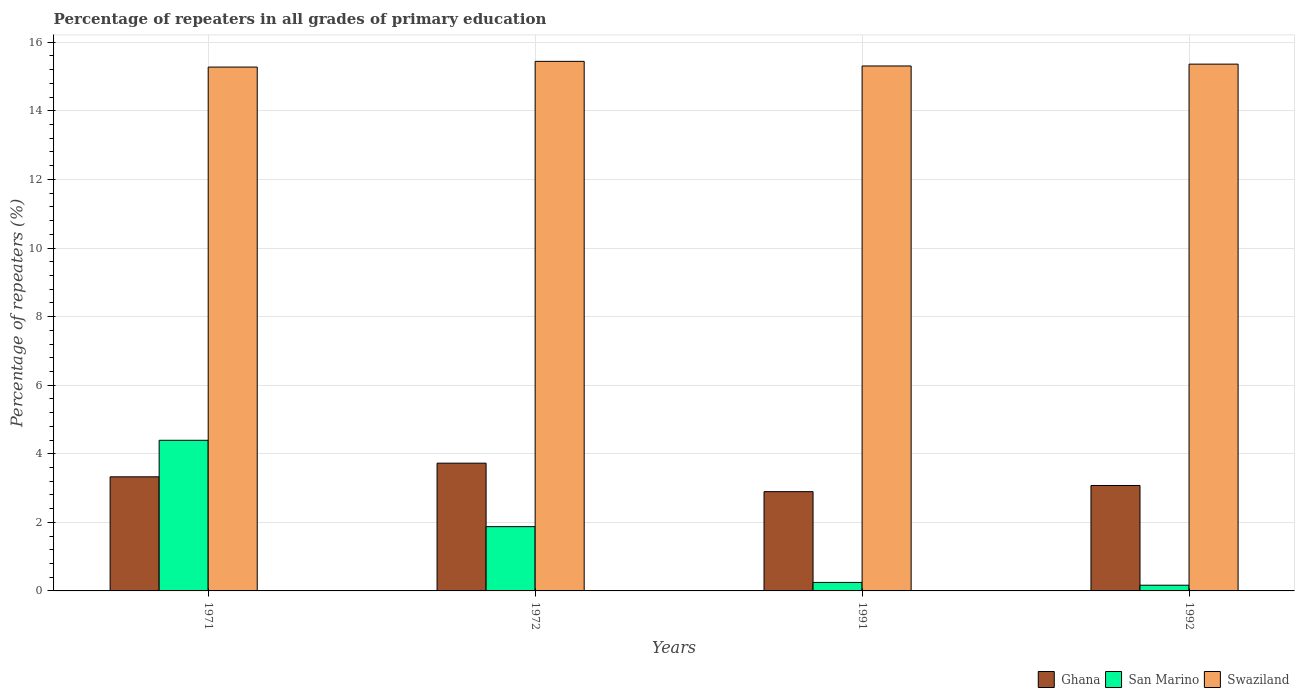How many different coloured bars are there?
Provide a succinct answer. 3. Are the number of bars per tick equal to the number of legend labels?
Provide a succinct answer. Yes. How many bars are there on the 2nd tick from the right?
Give a very brief answer. 3. What is the label of the 1st group of bars from the left?
Your response must be concise. 1971. In how many cases, is the number of bars for a given year not equal to the number of legend labels?
Provide a short and direct response. 0. What is the percentage of repeaters in San Marino in 1992?
Your answer should be compact. 0.17. Across all years, what is the maximum percentage of repeaters in Ghana?
Provide a short and direct response. 3.73. Across all years, what is the minimum percentage of repeaters in Swaziland?
Make the answer very short. 15.28. What is the total percentage of repeaters in Swaziland in the graph?
Your answer should be compact. 61.39. What is the difference between the percentage of repeaters in Ghana in 1971 and that in 1972?
Offer a very short reply. -0.4. What is the difference between the percentage of repeaters in Ghana in 1991 and the percentage of repeaters in Swaziland in 1972?
Your response must be concise. -12.55. What is the average percentage of repeaters in Ghana per year?
Offer a very short reply. 3.26. In the year 1972, what is the difference between the percentage of repeaters in Ghana and percentage of repeaters in San Marino?
Your answer should be very brief. 1.85. What is the ratio of the percentage of repeaters in Swaziland in 1991 to that in 1992?
Your answer should be very brief. 1. What is the difference between the highest and the second highest percentage of repeaters in Ghana?
Keep it short and to the point. 0.4. What is the difference between the highest and the lowest percentage of repeaters in San Marino?
Your answer should be compact. 4.23. Is the sum of the percentage of repeaters in San Marino in 1972 and 1991 greater than the maximum percentage of repeaters in Swaziland across all years?
Your response must be concise. No. What does the 2nd bar from the right in 1991 represents?
Ensure brevity in your answer.  San Marino. Is it the case that in every year, the sum of the percentage of repeaters in San Marino and percentage of repeaters in Ghana is greater than the percentage of repeaters in Swaziland?
Give a very brief answer. No. How many bars are there?
Your answer should be compact. 12. Are all the bars in the graph horizontal?
Provide a short and direct response. No. What is the difference between two consecutive major ticks on the Y-axis?
Your response must be concise. 2. Are the values on the major ticks of Y-axis written in scientific E-notation?
Your response must be concise. No. Where does the legend appear in the graph?
Ensure brevity in your answer.  Bottom right. What is the title of the graph?
Your answer should be compact. Percentage of repeaters in all grades of primary education. What is the label or title of the Y-axis?
Ensure brevity in your answer.  Percentage of repeaters (%). What is the Percentage of repeaters (%) in Ghana in 1971?
Provide a succinct answer. 3.33. What is the Percentage of repeaters (%) in San Marino in 1971?
Offer a very short reply. 4.39. What is the Percentage of repeaters (%) in Swaziland in 1971?
Offer a terse response. 15.28. What is the Percentage of repeaters (%) of Ghana in 1972?
Your answer should be compact. 3.73. What is the Percentage of repeaters (%) of San Marino in 1972?
Offer a very short reply. 1.87. What is the Percentage of repeaters (%) in Swaziland in 1972?
Offer a very short reply. 15.44. What is the Percentage of repeaters (%) in Ghana in 1991?
Provide a short and direct response. 2.9. What is the Percentage of repeaters (%) of San Marino in 1991?
Keep it short and to the point. 0.25. What is the Percentage of repeaters (%) of Swaziland in 1991?
Offer a very short reply. 15.31. What is the Percentage of repeaters (%) of Ghana in 1992?
Keep it short and to the point. 3.07. What is the Percentage of repeaters (%) of San Marino in 1992?
Offer a terse response. 0.17. What is the Percentage of repeaters (%) in Swaziland in 1992?
Offer a very short reply. 15.36. Across all years, what is the maximum Percentage of repeaters (%) in Ghana?
Your answer should be compact. 3.73. Across all years, what is the maximum Percentage of repeaters (%) of San Marino?
Ensure brevity in your answer.  4.39. Across all years, what is the maximum Percentage of repeaters (%) of Swaziland?
Your response must be concise. 15.44. Across all years, what is the minimum Percentage of repeaters (%) in Ghana?
Offer a very short reply. 2.9. Across all years, what is the minimum Percentage of repeaters (%) in San Marino?
Offer a very short reply. 0.17. Across all years, what is the minimum Percentage of repeaters (%) of Swaziland?
Provide a short and direct response. 15.28. What is the total Percentage of repeaters (%) of Ghana in the graph?
Keep it short and to the point. 13.02. What is the total Percentage of repeaters (%) of San Marino in the graph?
Offer a terse response. 6.68. What is the total Percentage of repeaters (%) of Swaziland in the graph?
Your response must be concise. 61.39. What is the difference between the Percentage of repeaters (%) of Ghana in 1971 and that in 1972?
Provide a succinct answer. -0.4. What is the difference between the Percentage of repeaters (%) of San Marino in 1971 and that in 1972?
Your answer should be compact. 2.52. What is the difference between the Percentage of repeaters (%) of Ghana in 1971 and that in 1991?
Ensure brevity in your answer.  0.43. What is the difference between the Percentage of repeaters (%) of San Marino in 1971 and that in 1991?
Give a very brief answer. 4.15. What is the difference between the Percentage of repeaters (%) in Swaziland in 1971 and that in 1991?
Give a very brief answer. -0.03. What is the difference between the Percentage of repeaters (%) in Ghana in 1971 and that in 1992?
Your answer should be compact. 0.25. What is the difference between the Percentage of repeaters (%) of San Marino in 1971 and that in 1992?
Keep it short and to the point. 4.23. What is the difference between the Percentage of repeaters (%) of Swaziland in 1971 and that in 1992?
Give a very brief answer. -0.09. What is the difference between the Percentage of repeaters (%) in Ghana in 1972 and that in 1991?
Provide a succinct answer. 0.83. What is the difference between the Percentage of repeaters (%) of San Marino in 1972 and that in 1991?
Give a very brief answer. 1.63. What is the difference between the Percentage of repeaters (%) in Swaziland in 1972 and that in 1991?
Give a very brief answer. 0.13. What is the difference between the Percentage of repeaters (%) in Ghana in 1972 and that in 1992?
Your response must be concise. 0.65. What is the difference between the Percentage of repeaters (%) of San Marino in 1972 and that in 1992?
Your answer should be very brief. 1.71. What is the difference between the Percentage of repeaters (%) of Swaziland in 1972 and that in 1992?
Your answer should be compact. 0.08. What is the difference between the Percentage of repeaters (%) in Ghana in 1991 and that in 1992?
Keep it short and to the point. -0.18. What is the difference between the Percentage of repeaters (%) of San Marino in 1991 and that in 1992?
Provide a succinct answer. 0.08. What is the difference between the Percentage of repeaters (%) in Swaziland in 1991 and that in 1992?
Your answer should be compact. -0.05. What is the difference between the Percentage of repeaters (%) in Ghana in 1971 and the Percentage of repeaters (%) in San Marino in 1972?
Offer a terse response. 1.45. What is the difference between the Percentage of repeaters (%) of Ghana in 1971 and the Percentage of repeaters (%) of Swaziland in 1972?
Provide a short and direct response. -12.12. What is the difference between the Percentage of repeaters (%) of San Marino in 1971 and the Percentage of repeaters (%) of Swaziland in 1972?
Your answer should be compact. -11.05. What is the difference between the Percentage of repeaters (%) of Ghana in 1971 and the Percentage of repeaters (%) of San Marino in 1991?
Make the answer very short. 3.08. What is the difference between the Percentage of repeaters (%) in Ghana in 1971 and the Percentage of repeaters (%) in Swaziland in 1991?
Make the answer very short. -11.98. What is the difference between the Percentage of repeaters (%) in San Marino in 1971 and the Percentage of repeaters (%) in Swaziland in 1991?
Offer a terse response. -10.92. What is the difference between the Percentage of repeaters (%) of Ghana in 1971 and the Percentage of repeaters (%) of San Marino in 1992?
Your response must be concise. 3.16. What is the difference between the Percentage of repeaters (%) of Ghana in 1971 and the Percentage of repeaters (%) of Swaziland in 1992?
Offer a terse response. -12.03. What is the difference between the Percentage of repeaters (%) in San Marino in 1971 and the Percentage of repeaters (%) in Swaziland in 1992?
Make the answer very short. -10.97. What is the difference between the Percentage of repeaters (%) in Ghana in 1972 and the Percentage of repeaters (%) in San Marino in 1991?
Ensure brevity in your answer.  3.48. What is the difference between the Percentage of repeaters (%) of Ghana in 1972 and the Percentage of repeaters (%) of Swaziland in 1991?
Provide a short and direct response. -11.58. What is the difference between the Percentage of repeaters (%) in San Marino in 1972 and the Percentage of repeaters (%) in Swaziland in 1991?
Keep it short and to the point. -13.43. What is the difference between the Percentage of repeaters (%) in Ghana in 1972 and the Percentage of repeaters (%) in San Marino in 1992?
Offer a very short reply. 3.56. What is the difference between the Percentage of repeaters (%) of Ghana in 1972 and the Percentage of repeaters (%) of Swaziland in 1992?
Offer a very short reply. -11.64. What is the difference between the Percentage of repeaters (%) of San Marino in 1972 and the Percentage of repeaters (%) of Swaziland in 1992?
Offer a terse response. -13.49. What is the difference between the Percentage of repeaters (%) in Ghana in 1991 and the Percentage of repeaters (%) in San Marino in 1992?
Offer a very short reply. 2.73. What is the difference between the Percentage of repeaters (%) of Ghana in 1991 and the Percentage of repeaters (%) of Swaziland in 1992?
Your answer should be very brief. -12.47. What is the difference between the Percentage of repeaters (%) in San Marino in 1991 and the Percentage of repeaters (%) in Swaziland in 1992?
Keep it short and to the point. -15.11. What is the average Percentage of repeaters (%) of Ghana per year?
Your answer should be compact. 3.26. What is the average Percentage of repeaters (%) of San Marino per year?
Make the answer very short. 1.67. What is the average Percentage of repeaters (%) of Swaziland per year?
Make the answer very short. 15.35. In the year 1971, what is the difference between the Percentage of repeaters (%) in Ghana and Percentage of repeaters (%) in San Marino?
Ensure brevity in your answer.  -1.07. In the year 1971, what is the difference between the Percentage of repeaters (%) of Ghana and Percentage of repeaters (%) of Swaziland?
Provide a short and direct response. -11.95. In the year 1971, what is the difference between the Percentage of repeaters (%) of San Marino and Percentage of repeaters (%) of Swaziland?
Offer a very short reply. -10.88. In the year 1972, what is the difference between the Percentage of repeaters (%) in Ghana and Percentage of repeaters (%) in San Marino?
Offer a terse response. 1.85. In the year 1972, what is the difference between the Percentage of repeaters (%) of Ghana and Percentage of repeaters (%) of Swaziland?
Ensure brevity in your answer.  -11.72. In the year 1972, what is the difference between the Percentage of repeaters (%) of San Marino and Percentage of repeaters (%) of Swaziland?
Provide a short and direct response. -13.57. In the year 1991, what is the difference between the Percentage of repeaters (%) in Ghana and Percentage of repeaters (%) in San Marino?
Provide a short and direct response. 2.65. In the year 1991, what is the difference between the Percentage of repeaters (%) in Ghana and Percentage of repeaters (%) in Swaziland?
Your response must be concise. -12.41. In the year 1991, what is the difference between the Percentage of repeaters (%) of San Marino and Percentage of repeaters (%) of Swaziland?
Make the answer very short. -15.06. In the year 1992, what is the difference between the Percentage of repeaters (%) of Ghana and Percentage of repeaters (%) of San Marino?
Provide a succinct answer. 2.91. In the year 1992, what is the difference between the Percentage of repeaters (%) of Ghana and Percentage of repeaters (%) of Swaziland?
Offer a terse response. -12.29. In the year 1992, what is the difference between the Percentage of repeaters (%) in San Marino and Percentage of repeaters (%) in Swaziland?
Keep it short and to the point. -15.2. What is the ratio of the Percentage of repeaters (%) in Ghana in 1971 to that in 1972?
Keep it short and to the point. 0.89. What is the ratio of the Percentage of repeaters (%) in San Marino in 1971 to that in 1972?
Ensure brevity in your answer.  2.34. What is the ratio of the Percentage of repeaters (%) of Ghana in 1971 to that in 1991?
Offer a very short reply. 1.15. What is the ratio of the Percentage of repeaters (%) of San Marino in 1971 to that in 1991?
Provide a short and direct response. 17.75. What is the ratio of the Percentage of repeaters (%) of Ghana in 1971 to that in 1992?
Make the answer very short. 1.08. What is the ratio of the Percentage of repeaters (%) in San Marino in 1971 to that in 1992?
Make the answer very short. 26.36. What is the ratio of the Percentage of repeaters (%) of Swaziland in 1971 to that in 1992?
Your answer should be very brief. 0.99. What is the ratio of the Percentage of repeaters (%) of Ghana in 1972 to that in 1991?
Offer a terse response. 1.29. What is the ratio of the Percentage of repeaters (%) of San Marino in 1972 to that in 1991?
Your response must be concise. 7.57. What is the ratio of the Percentage of repeaters (%) of Swaziland in 1972 to that in 1991?
Your answer should be compact. 1.01. What is the ratio of the Percentage of repeaters (%) in Ghana in 1972 to that in 1992?
Keep it short and to the point. 1.21. What is the ratio of the Percentage of repeaters (%) of San Marino in 1972 to that in 1992?
Provide a short and direct response. 11.25. What is the ratio of the Percentage of repeaters (%) in Ghana in 1991 to that in 1992?
Provide a succinct answer. 0.94. What is the ratio of the Percentage of repeaters (%) of San Marino in 1991 to that in 1992?
Your answer should be compact. 1.49. What is the ratio of the Percentage of repeaters (%) of Swaziland in 1991 to that in 1992?
Ensure brevity in your answer.  1. What is the difference between the highest and the second highest Percentage of repeaters (%) of Ghana?
Offer a very short reply. 0.4. What is the difference between the highest and the second highest Percentage of repeaters (%) of San Marino?
Provide a short and direct response. 2.52. What is the difference between the highest and the second highest Percentage of repeaters (%) in Swaziland?
Provide a short and direct response. 0.08. What is the difference between the highest and the lowest Percentage of repeaters (%) of Ghana?
Keep it short and to the point. 0.83. What is the difference between the highest and the lowest Percentage of repeaters (%) of San Marino?
Provide a succinct answer. 4.23. What is the difference between the highest and the lowest Percentage of repeaters (%) of Swaziland?
Offer a terse response. 0.17. 